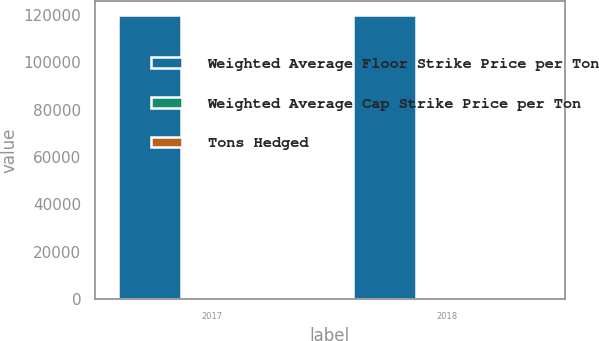<chart> <loc_0><loc_0><loc_500><loc_500><stacked_bar_chart><ecel><fcel>2017<fcel>2018<nl><fcel>Weighted Average Floor Strike Price per Ton<fcel>120000<fcel>120000<nl><fcel>Weighted Average Cap Strike Price per Ton<fcel>81.5<fcel>81.5<nl><fcel>Tons Hedged<fcel>120<fcel>120<nl></chart> 